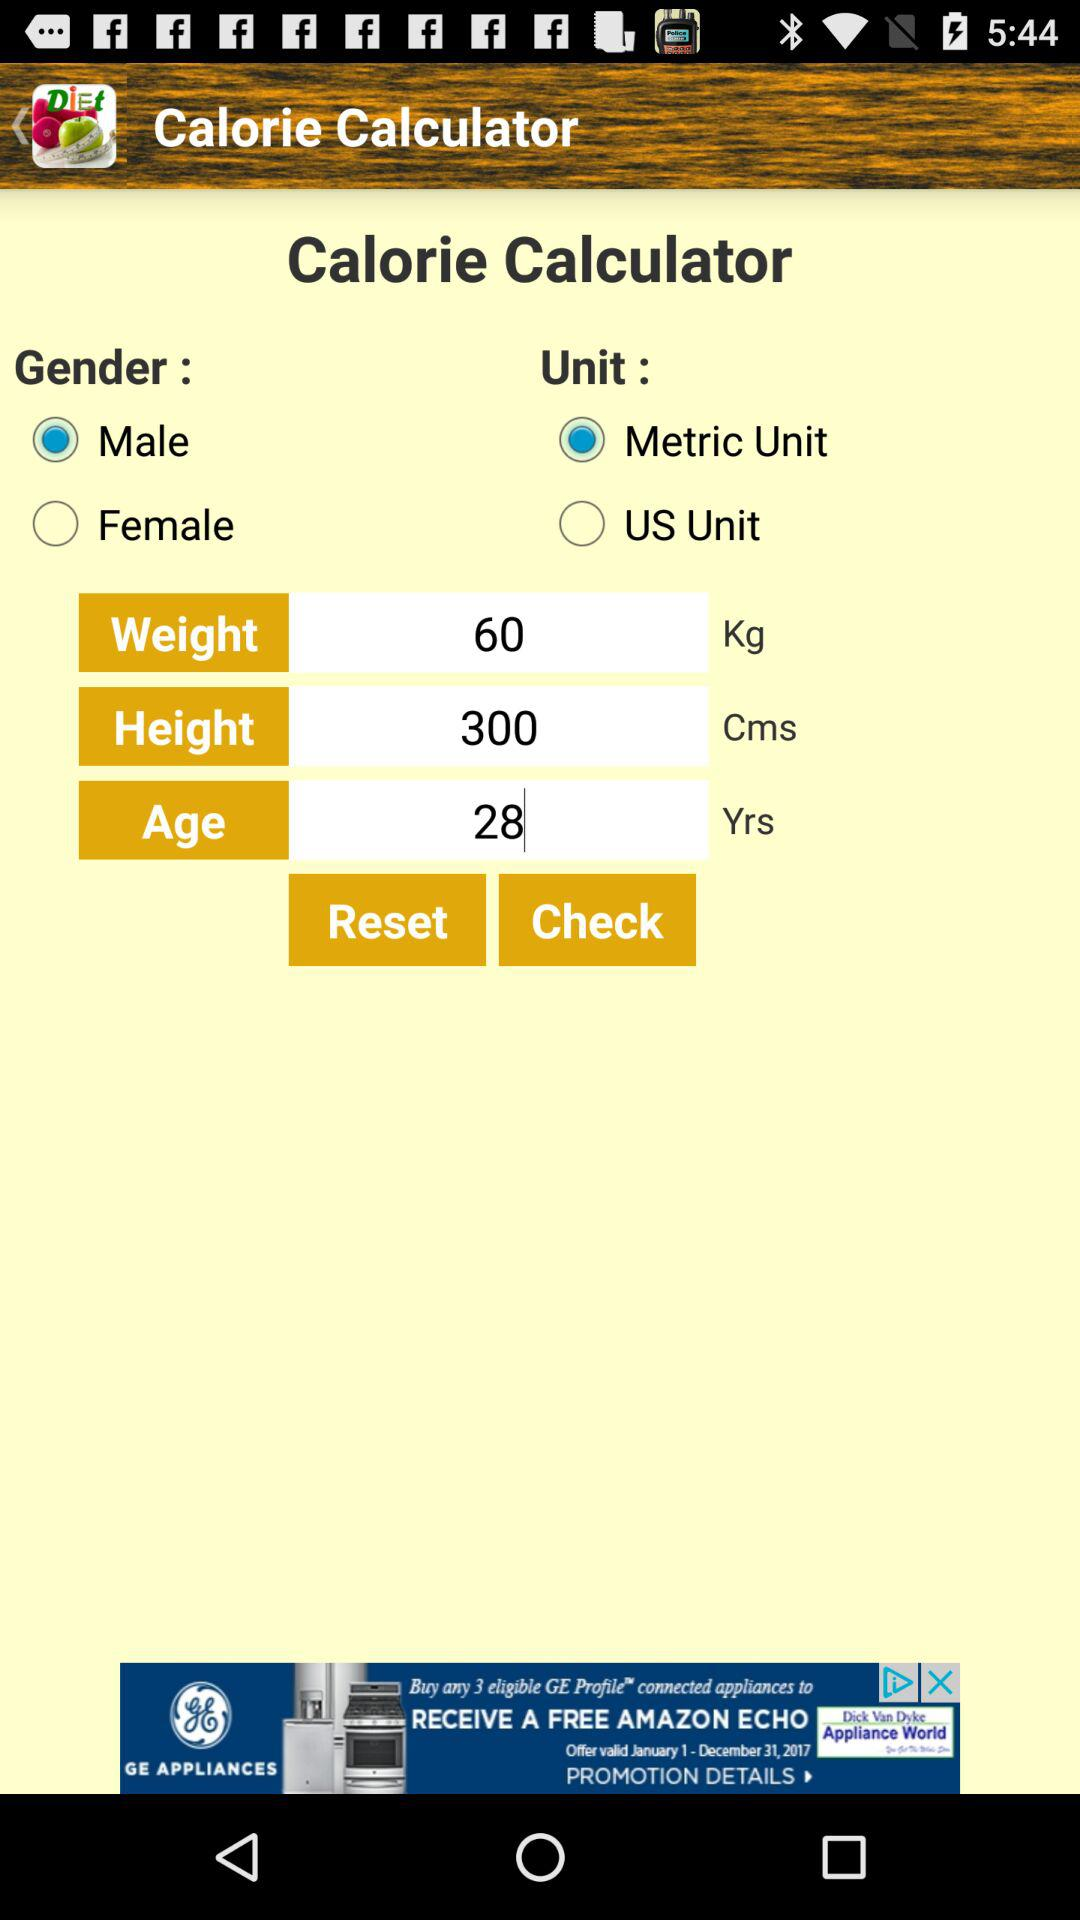What is the selected gender? The selected gender is male. 